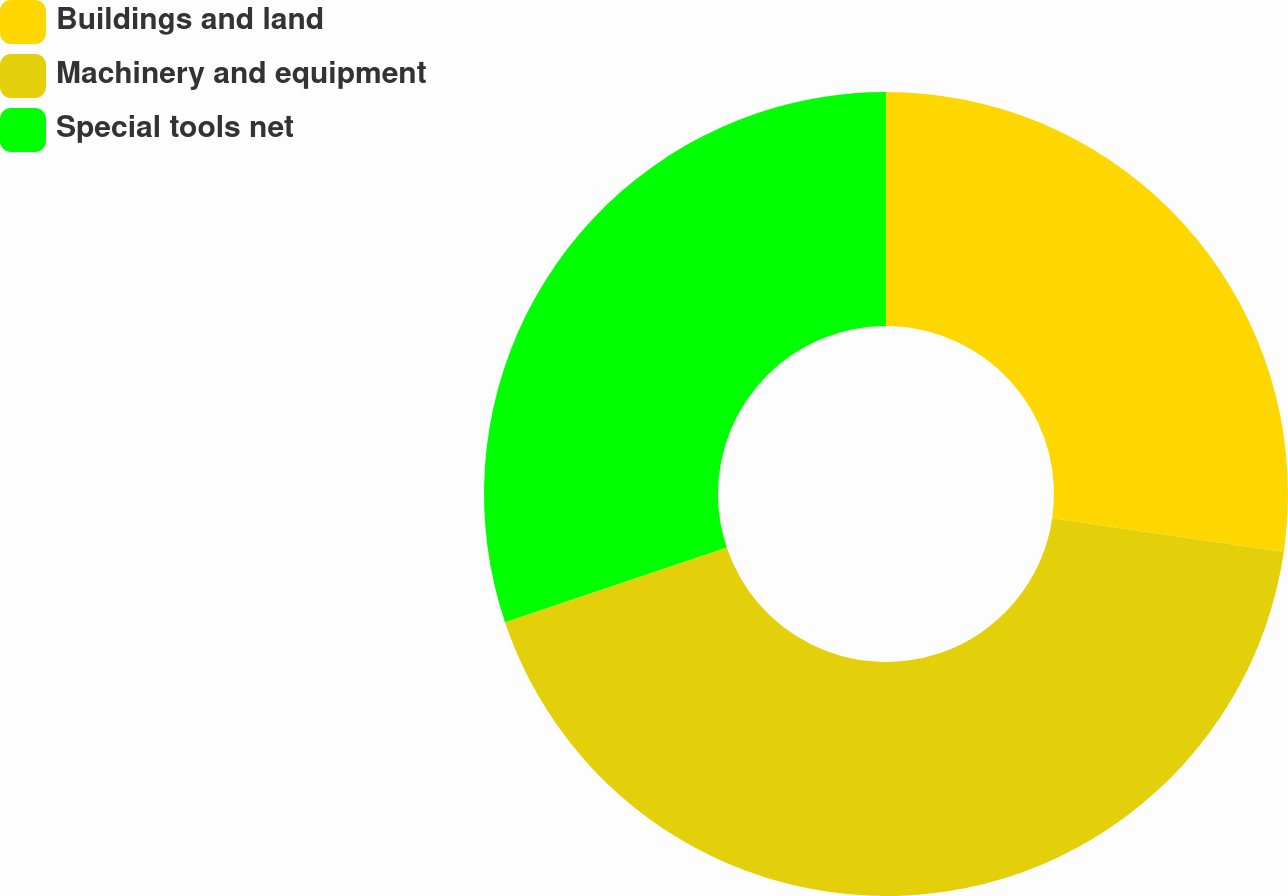Convert chart. <chart><loc_0><loc_0><loc_500><loc_500><pie_chart><fcel>Buildings and land<fcel>Machinery and equipment<fcel>Special tools net<nl><fcel>27.3%<fcel>42.53%<fcel>30.17%<nl></chart> 